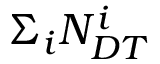<formula> <loc_0><loc_0><loc_500><loc_500>\Sigma _ { i } N _ { D T } ^ { i }</formula> 